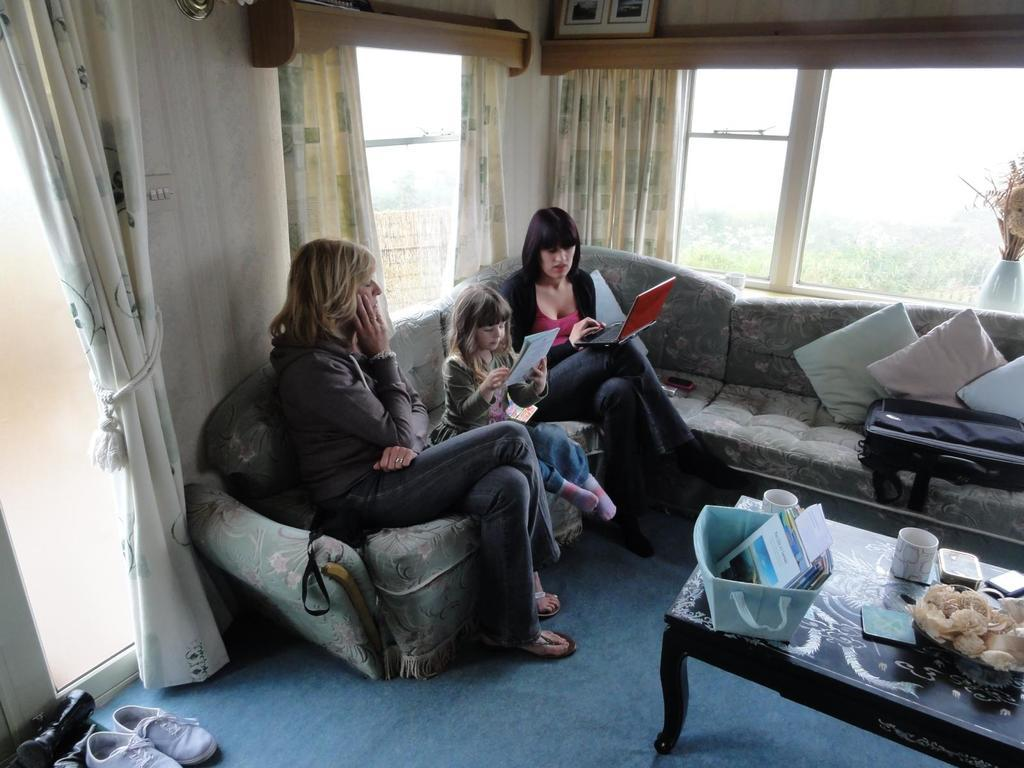What are the people in the image doing? There are people sitting on a couch in the image. Can you describe the gender of the individuals on the couch? Among the people on the couch, there are two women. What activity is one of the women engaged in? One of the women is operating a laptop. What is the girl on the couch doing? The girl on the couch is reading. What type of yarn is the goose using to knit a scarf in the image? There is no goose or yarn present in the image. Who is serving the people on the couch in the image? There is no servant or indication of someone serving the people in the image. 